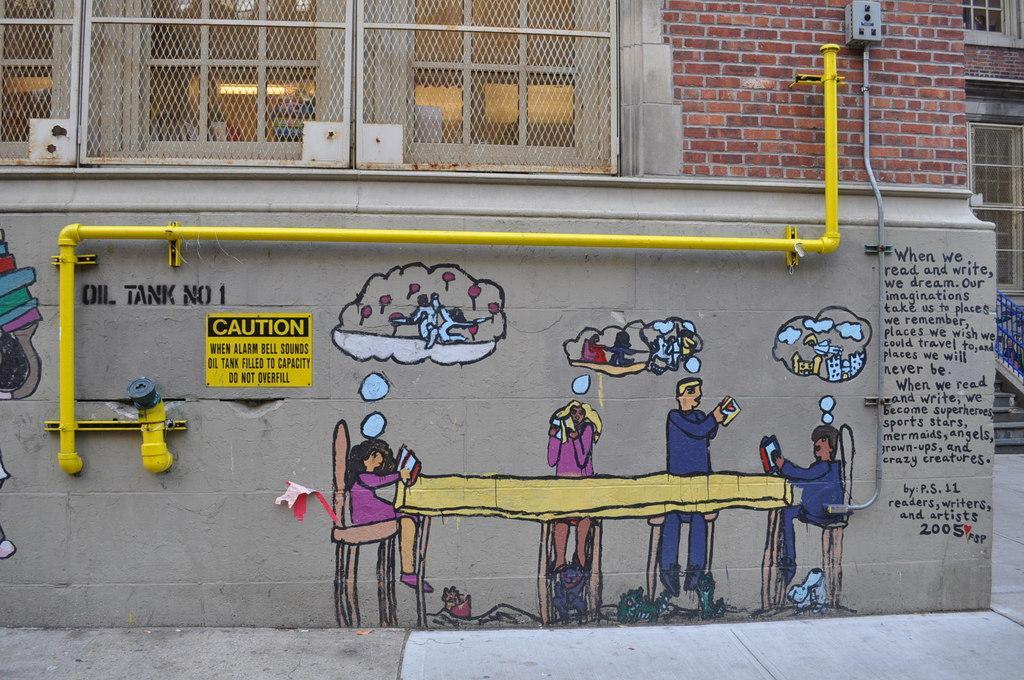Describe this image in one or two sentences. In this picture I can see a building and I can see painting on the wall and I can see text. 